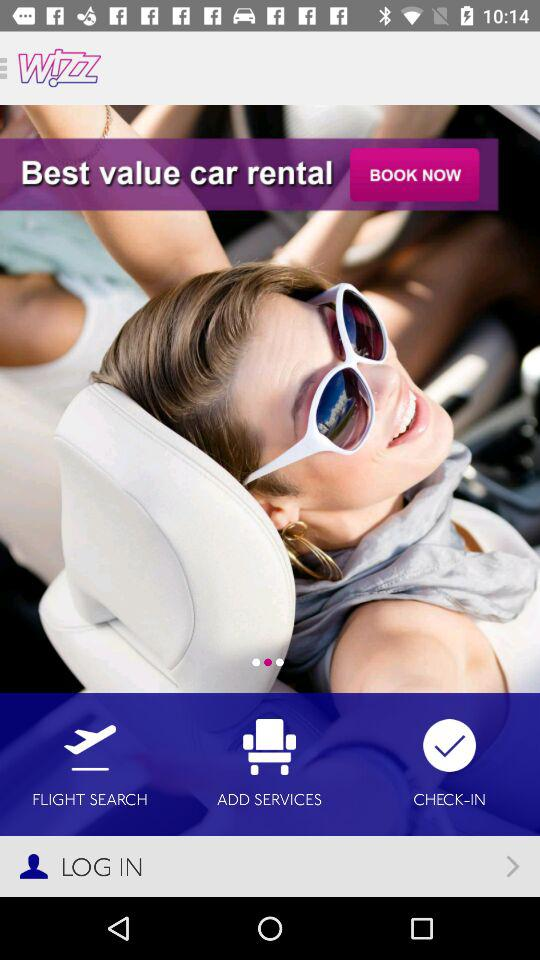How much does it cost to rent a car?
When the provided information is insufficient, respond with <no answer>. <no answer> 